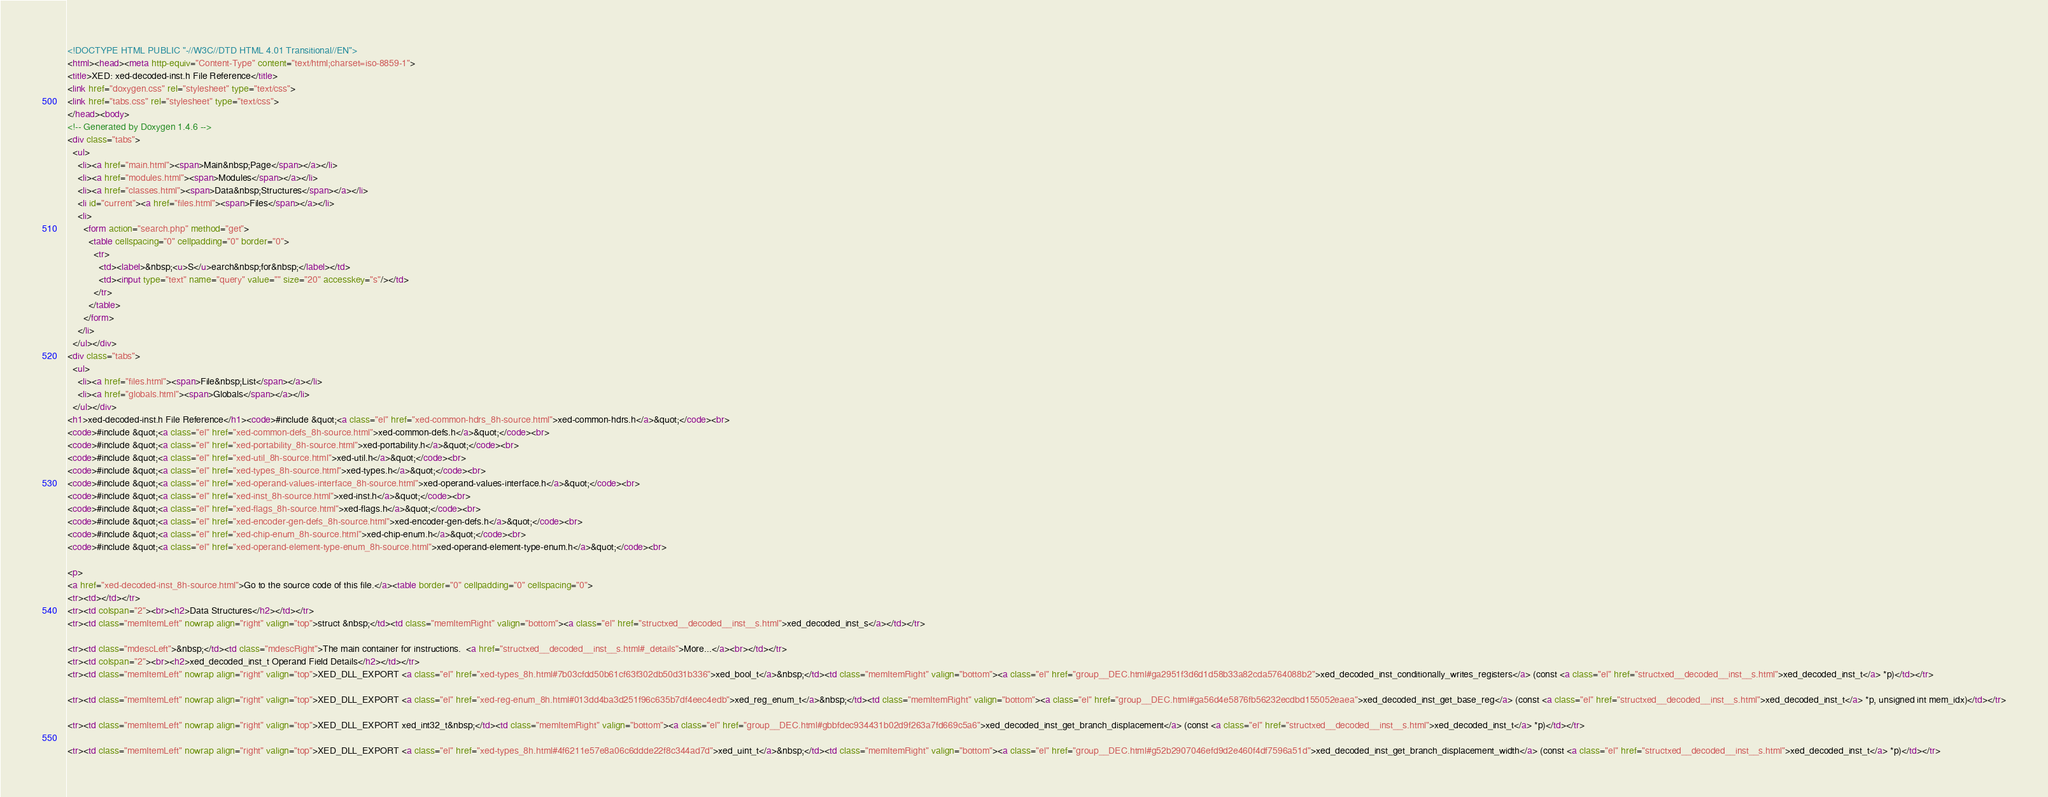Convert code to text. <code><loc_0><loc_0><loc_500><loc_500><_HTML_><!DOCTYPE HTML PUBLIC "-//W3C//DTD HTML 4.01 Transitional//EN">
<html><head><meta http-equiv="Content-Type" content="text/html;charset=iso-8859-1">
<title>XED: xed-decoded-inst.h File Reference</title>
<link href="doxygen.css" rel="stylesheet" type="text/css">
<link href="tabs.css" rel="stylesheet" type="text/css">
</head><body>
<!-- Generated by Doxygen 1.4.6 -->
<div class="tabs">
  <ul>
    <li><a href="main.html"><span>Main&nbsp;Page</span></a></li>
    <li><a href="modules.html"><span>Modules</span></a></li>
    <li><a href="classes.html"><span>Data&nbsp;Structures</span></a></li>
    <li id="current"><a href="files.html"><span>Files</span></a></li>
    <li>
      <form action="search.php" method="get">
        <table cellspacing="0" cellpadding="0" border="0">
          <tr>
            <td><label>&nbsp;<u>S</u>earch&nbsp;for&nbsp;</label></td>
            <td><input type="text" name="query" value="" size="20" accesskey="s"/></td>
          </tr>
        </table>
      </form>
    </li>
  </ul></div>
<div class="tabs">
  <ul>
    <li><a href="files.html"><span>File&nbsp;List</span></a></li>
    <li><a href="globals.html"><span>Globals</span></a></li>
  </ul></div>
<h1>xed-decoded-inst.h File Reference</h1><code>#include &quot;<a class="el" href="xed-common-hdrs_8h-source.html">xed-common-hdrs.h</a>&quot;</code><br>
<code>#include &quot;<a class="el" href="xed-common-defs_8h-source.html">xed-common-defs.h</a>&quot;</code><br>
<code>#include &quot;<a class="el" href="xed-portability_8h-source.html">xed-portability.h</a>&quot;</code><br>
<code>#include &quot;<a class="el" href="xed-util_8h-source.html">xed-util.h</a>&quot;</code><br>
<code>#include &quot;<a class="el" href="xed-types_8h-source.html">xed-types.h</a>&quot;</code><br>
<code>#include &quot;<a class="el" href="xed-operand-values-interface_8h-source.html">xed-operand-values-interface.h</a>&quot;</code><br>
<code>#include &quot;<a class="el" href="xed-inst_8h-source.html">xed-inst.h</a>&quot;</code><br>
<code>#include &quot;<a class="el" href="xed-flags_8h-source.html">xed-flags.h</a>&quot;</code><br>
<code>#include &quot;<a class="el" href="xed-encoder-gen-defs_8h-source.html">xed-encoder-gen-defs.h</a>&quot;</code><br>
<code>#include &quot;<a class="el" href="xed-chip-enum_8h-source.html">xed-chip-enum.h</a>&quot;</code><br>
<code>#include &quot;<a class="el" href="xed-operand-element-type-enum_8h-source.html">xed-operand-element-type-enum.h</a>&quot;</code><br>

<p>
<a href="xed-decoded-inst_8h-source.html">Go to the source code of this file.</a><table border="0" cellpadding="0" cellspacing="0">
<tr><td></td></tr>
<tr><td colspan="2"><br><h2>Data Structures</h2></td></tr>
<tr><td class="memItemLeft" nowrap align="right" valign="top">struct &nbsp;</td><td class="memItemRight" valign="bottom"><a class="el" href="structxed__decoded__inst__s.html">xed_decoded_inst_s</a></td></tr>

<tr><td class="mdescLeft">&nbsp;</td><td class="mdescRight">The main container for instructions.  <a href="structxed__decoded__inst__s.html#_details">More...</a><br></td></tr>
<tr><td colspan="2"><br><h2>xed_decoded_inst_t Operand Field Details</h2></td></tr>
<tr><td class="memItemLeft" nowrap align="right" valign="top">XED_DLL_EXPORT <a class="el" href="xed-types_8h.html#7b03cfdd50b61cf63f302db50d31b336">xed_bool_t</a>&nbsp;</td><td class="memItemRight" valign="bottom"><a class="el" href="group__DEC.html#ga2951f3d6d1d58b33a82cda5764088b2">xed_decoded_inst_conditionally_writes_registers</a> (const <a class="el" href="structxed__decoded__inst__s.html">xed_decoded_inst_t</a> *p)</td></tr>

<tr><td class="memItemLeft" nowrap align="right" valign="top">XED_DLL_EXPORT <a class="el" href="xed-reg-enum_8h.html#013dd4ba3d251f96c635b7df4eec4edb">xed_reg_enum_t</a>&nbsp;</td><td class="memItemRight" valign="bottom"><a class="el" href="group__DEC.html#ga56d4e5876fb56232ecdbd155052eaea">xed_decoded_inst_get_base_reg</a> (const <a class="el" href="structxed__decoded__inst__s.html">xed_decoded_inst_t</a> *p, unsigned int mem_idx)</td></tr>

<tr><td class="memItemLeft" nowrap align="right" valign="top">XED_DLL_EXPORT xed_int32_t&nbsp;</td><td class="memItemRight" valign="bottom"><a class="el" href="group__DEC.html#gbbfdec934431b02d9f263a7fd669c5a6">xed_decoded_inst_get_branch_displacement</a> (const <a class="el" href="structxed__decoded__inst__s.html">xed_decoded_inst_t</a> *p)</td></tr>

<tr><td class="memItemLeft" nowrap align="right" valign="top">XED_DLL_EXPORT <a class="el" href="xed-types_8h.html#4f6211e57e8a06c6ddde22f8c344ad7d">xed_uint_t</a>&nbsp;</td><td class="memItemRight" valign="bottom"><a class="el" href="group__DEC.html#g52b2907046efd9d2e460f4df7596a51d">xed_decoded_inst_get_branch_displacement_width</a> (const <a class="el" href="structxed__decoded__inst__s.html">xed_decoded_inst_t</a> *p)</td></tr>
</code> 